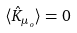Convert formula to latex. <formula><loc_0><loc_0><loc_500><loc_500>\langle \hat { K } _ { \mu _ { o } } \rangle = 0</formula> 